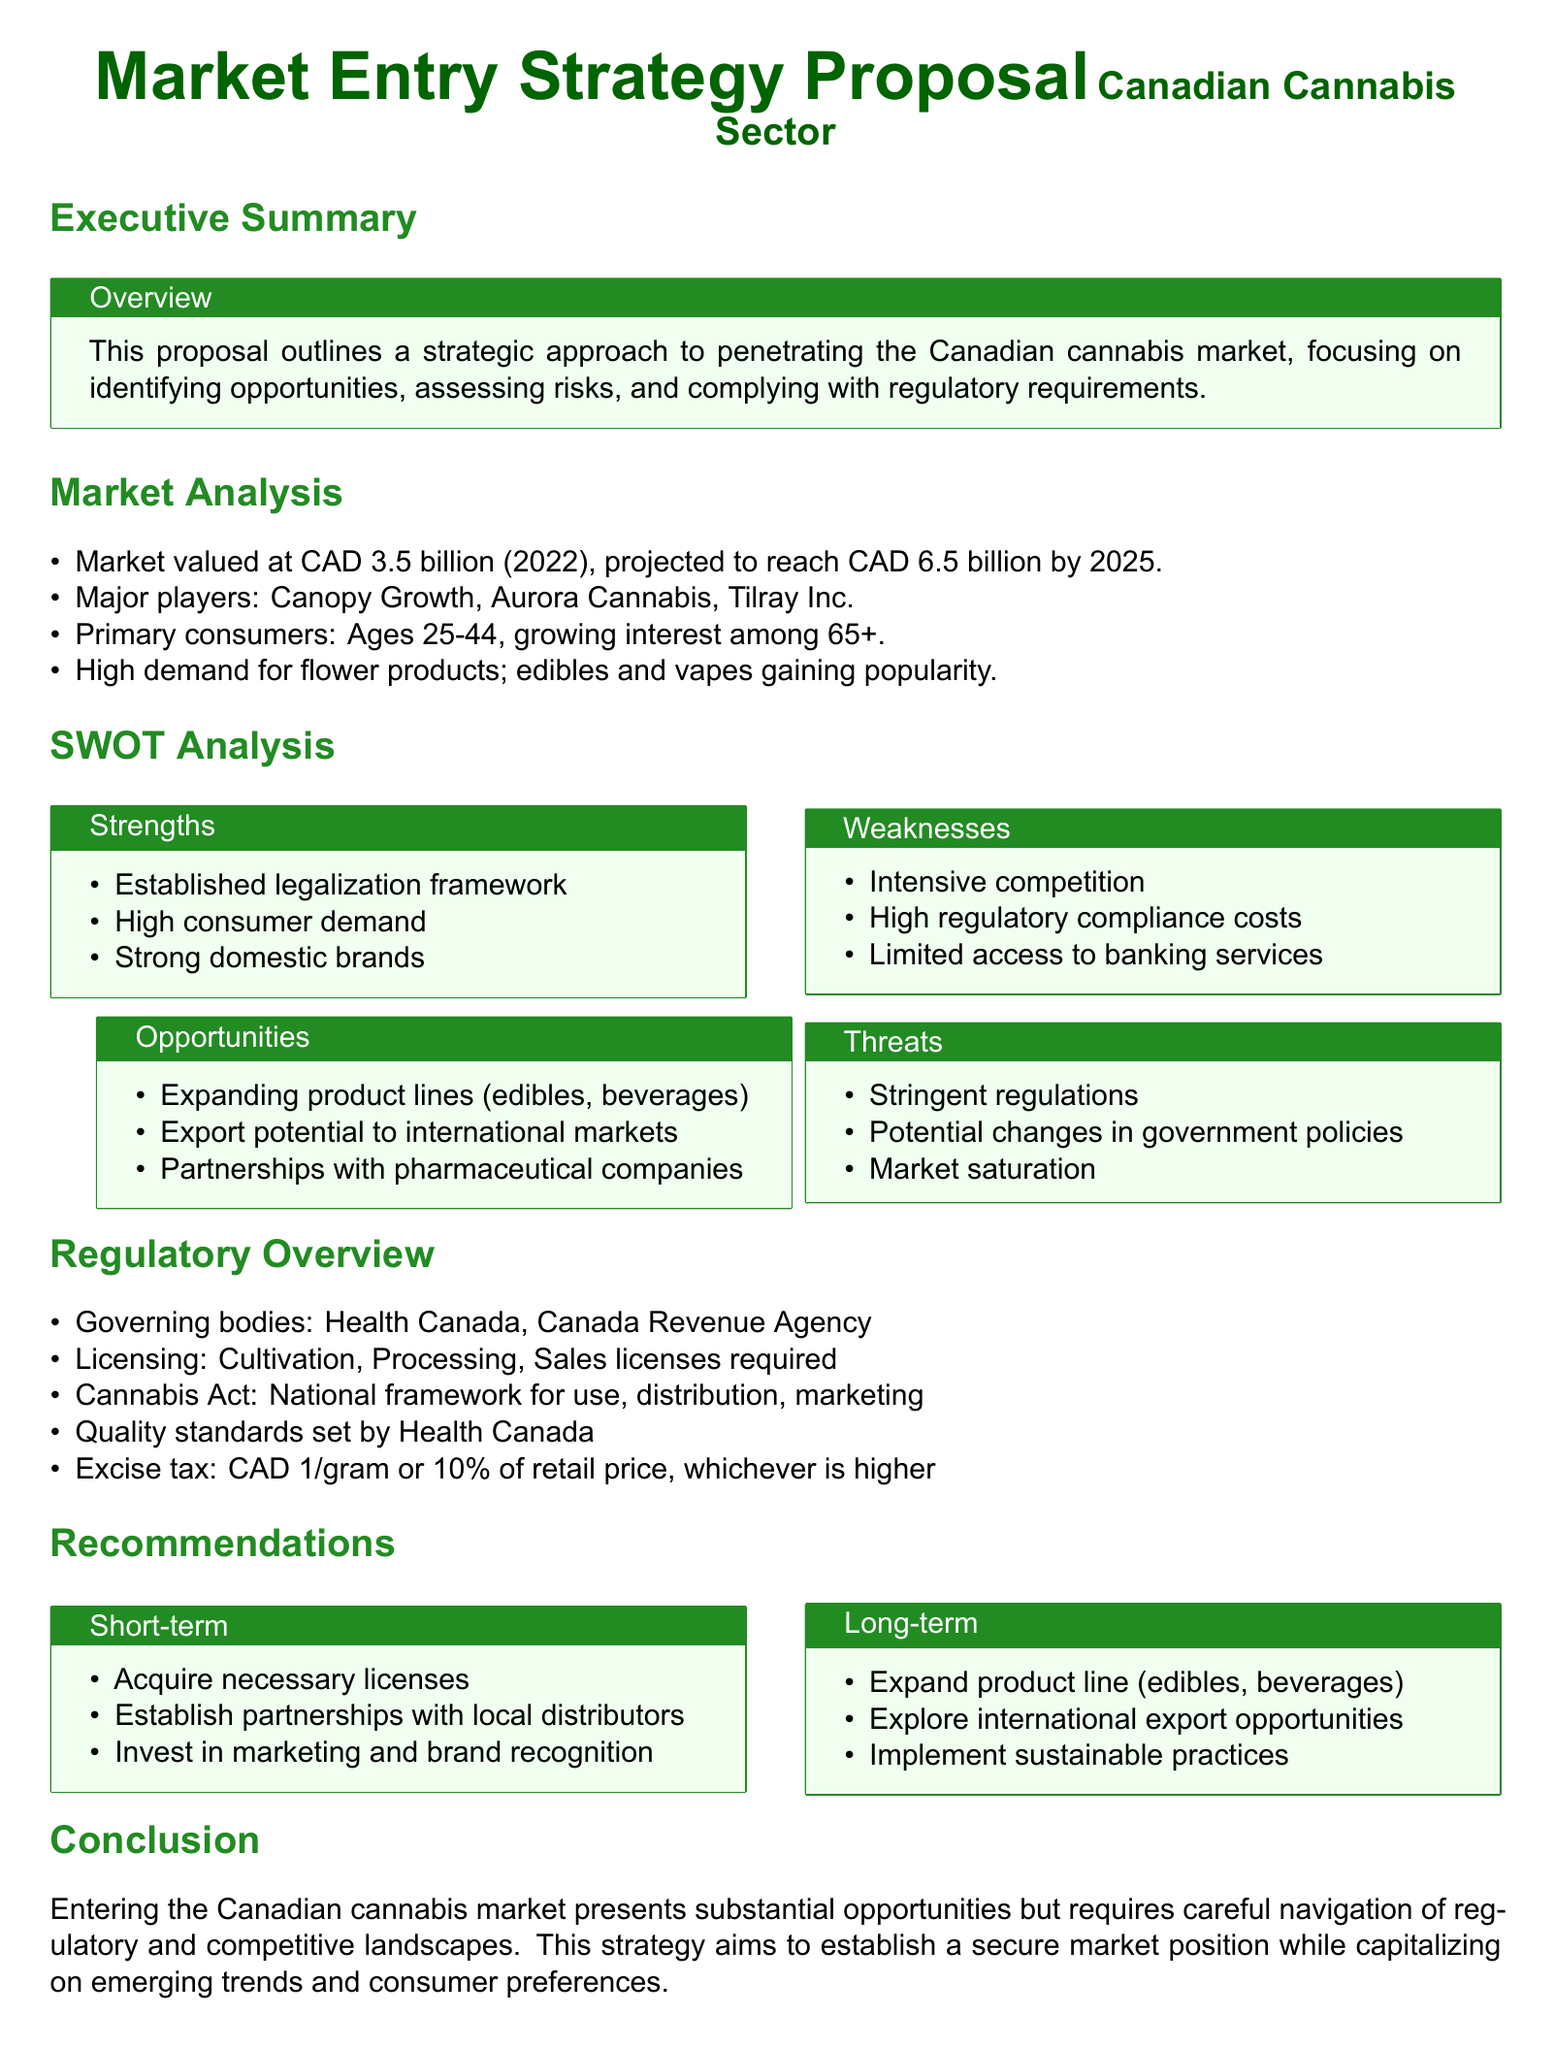What is the market value in 2022? The document states the market valued at CAD 3.5 billion in 2022.
Answer: CAD 3.5 billion What is projected market value by 2025? The projected market value is mentioned in the document as reaching CAD 6.5 billion by 2025.
Answer: CAD 6.5 billion Who are the major players in the market? The document lists Canopy Growth, Aurora Cannabis, and Tilray Inc. as major players.
Answer: Canopy Growth, Aurora Cannabis, Tilray Inc What is one of the strengths identified in the SWOT Analysis? The document specifies "Established legalization framework" as one of the strengths.
Answer: Established legalization framework What are the two short-term recommendations? The recommendations include acquiring necessary licenses and establishing partnerships with local distributors.
Answer: Acquire necessary licenses, establish partnerships with local distributors What is the excise tax rate mentioned in the regulatory overview? The document states the excise tax is CAD 1/gram or 10% of retail price, whichever is higher.
Answer: CAD 1/gram or 10% of retail price Who governs the Canadian cannabis regulations? The governing bodies mentioned in the regulatory overview are Health Canada and the Canada Revenue Agency.
Answer: Health Canada, Canada Revenue Agency What is one opportunity identified in the SWOT Analysis? The document identifies "Expanding product lines (edibles, beverages)" as an opportunity.
Answer: Expanding product lines (edibles, beverages) 